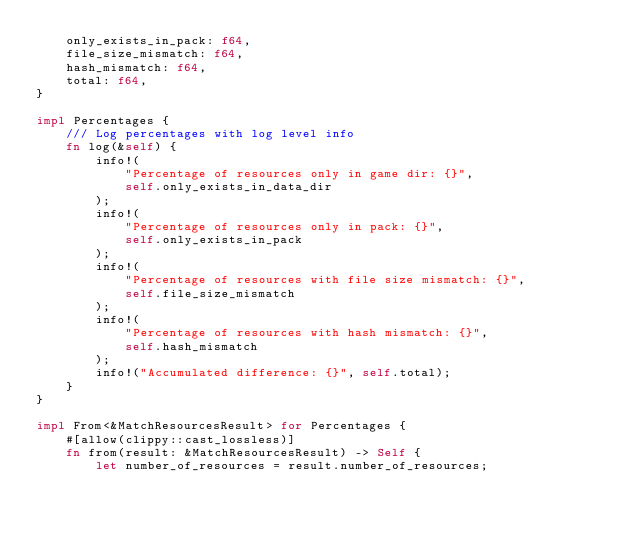<code> <loc_0><loc_0><loc_500><loc_500><_Rust_>    only_exists_in_pack: f64,
    file_size_mismatch: f64,
    hash_mismatch: f64,
    total: f64,
}

impl Percentages {
    /// Log percentages with log level info
    fn log(&self) {
        info!(
            "Percentage of resources only in game dir: {}",
            self.only_exists_in_data_dir
        );
        info!(
            "Percentage of resources only in pack: {}",
            self.only_exists_in_pack
        );
        info!(
            "Percentage of resources with file size mismatch: {}",
            self.file_size_mismatch
        );
        info!(
            "Percentage of resources with hash mismatch: {}",
            self.hash_mismatch
        );
        info!("Accumulated difference: {}", self.total);
    }
}

impl From<&MatchResourcesResult> for Percentages {
    #[allow(clippy::cast_lossless)]
    fn from(result: &MatchResourcesResult) -> Self {
        let number_of_resources = result.number_of_resources;</code> 